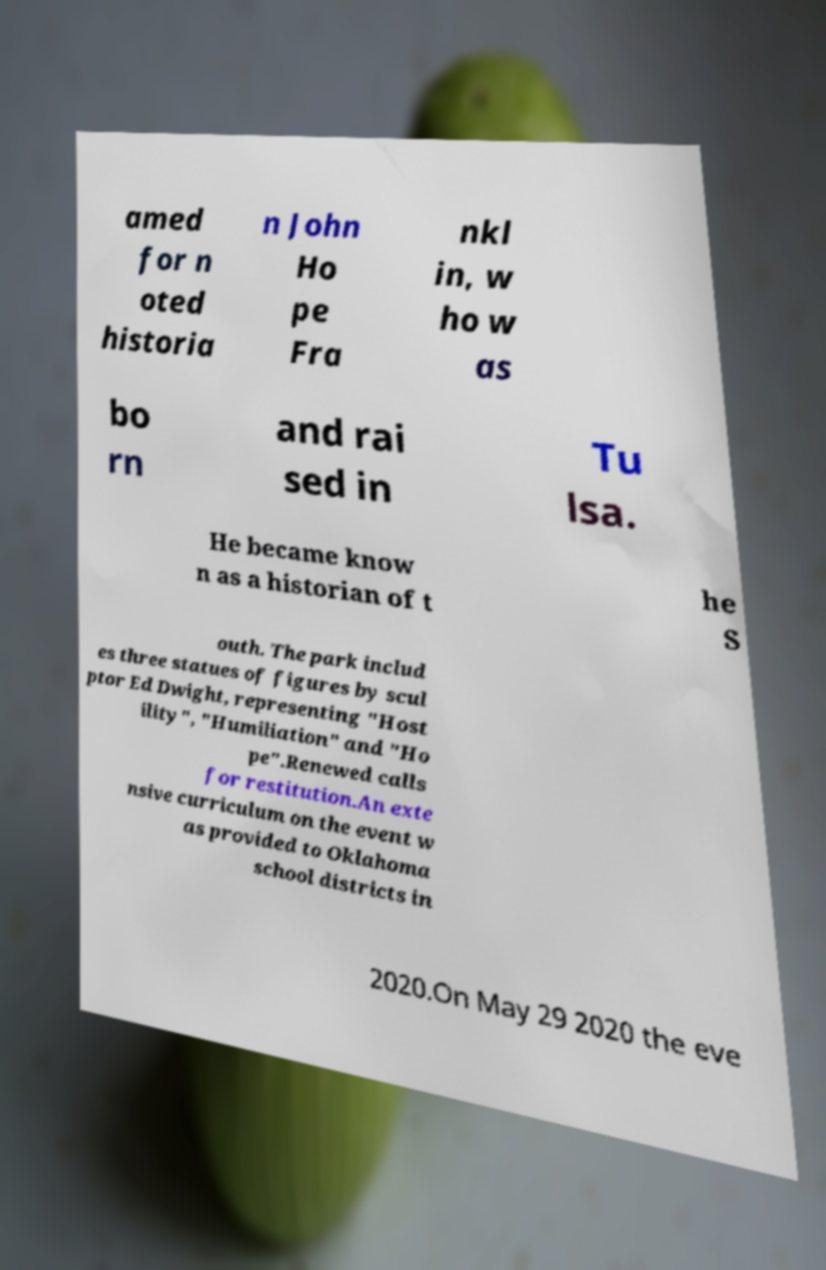There's text embedded in this image that I need extracted. Can you transcribe it verbatim? amed for n oted historia n John Ho pe Fra nkl in, w ho w as bo rn and rai sed in Tu lsa. He became know n as a historian of t he S outh. The park includ es three statues of figures by scul ptor Ed Dwight, representing "Host ility", "Humiliation" and "Ho pe".Renewed calls for restitution.An exte nsive curriculum on the event w as provided to Oklahoma school districts in 2020.On May 29 2020 the eve 